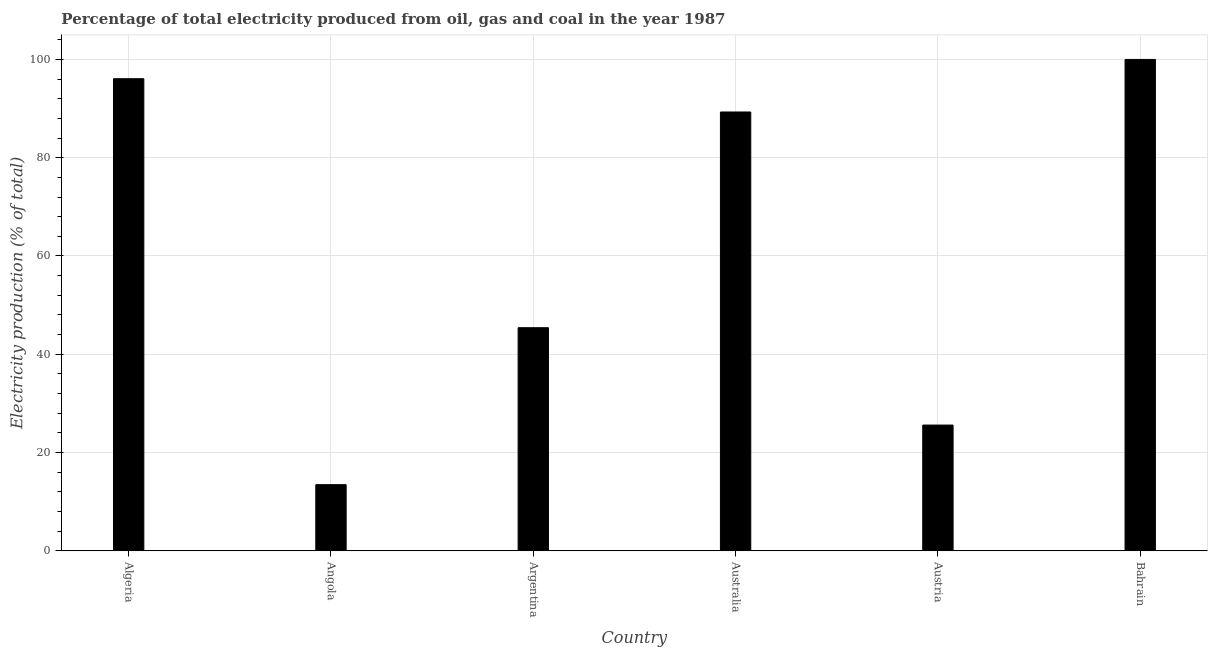Does the graph contain any zero values?
Keep it short and to the point. No. What is the title of the graph?
Your response must be concise. Percentage of total electricity produced from oil, gas and coal in the year 1987. What is the label or title of the Y-axis?
Provide a succinct answer. Electricity production (% of total). Across all countries, what is the minimum electricity production?
Provide a short and direct response. 13.46. In which country was the electricity production maximum?
Your response must be concise. Bahrain. In which country was the electricity production minimum?
Keep it short and to the point. Angola. What is the sum of the electricity production?
Give a very brief answer. 369.82. What is the difference between the electricity production in Argentina and Austria?
Keep it short and to the point. 19.82. What is the average electricity production per country?
Ensure brevity in your answer.  61.64. What is the median electricity production?
Provide a succinct answer. 67.35. In how many countries, is the electricity production greater than 76 %?
Ensure brevity in your answer.  3. What is the ratio of the electricity production in Australia to that in Austria?
Give a very brief answer. 3.49. What is the difference between the highest and the second highest electricity production?
Offer a very short reply. 3.92. What is the difference between the highest and the lowest electricity production?
Keep it short and to the point. 86.54. How many bars are there?
Your answer should be compact. 6. What is the difference between two consecutive major ticks on the Y-axis?
Provide a short and direct response. 20. Are the values on the major ticks of Y-axis written in scientific E-notation?
Offer a terse response. No. What is the Electricity production (% of total) of Algeria?
Offer a terse response. 96.08. What is the Electricity production (% of total) in Angola?
Give a very brief answer. 13.46. What is the Electricity production (% of total) of Argentina?
Your answer should be very brief. 45.4. What is the Electricity production (% of total) of Australia?
Make the answer very short. 89.3. What is the Electricity production (% of total) of Austria?
Provide a short and direct response. 25.58. What is the Electricity production (% of total) of Bahrain?
Give a very brief answer. 100. What is the difference between the Electricity production (% of total) in Algeria and Angola?
Make the answer very short. 82.62. What is the difference between the Electricity production (% of total) in Algeria and Argentina?
Offer a very short reply. 50.68. What is the difference between the Electricity production (% of total) in Algeria and Australia?
Ensure brevity in your answer.  6.77. What is the difference between the Electricity production (% of total) in Algeria and Austria?
Offer a very short reply. 70.49. What is the difference between the Electricity production (% of total) in Algeria and Bahrain?
Make the answer very short. -3.92. What is the difference between the Electricity production (% of total) in Angola and Argentina?
Your answer should be very brief. -31.94. What is the difference between the Electricity production (% of total) in Angola and Australia?
Your answer should be very brief. -75.85. What is the difference between the Electricity production (% of total) in Angola and Austria?
Make the answer very short. -12.13. What is the difference between the Electricity production (% of total) in Angola and Bahrain?
Provide a succinct answer. -86.54. What is the difference between the Electricity production (% of total) in Argentina and Australia?
Keep it short and to the point. -43.91. What is the difference between the Electricity production (% of total) in Argentina and Austria?
Your response must be concise. 19.82. What is the difference between the Electricity production (% of total) in Argentina and Bahrain?
Offer a very short reply. -54.6. What is the difference between the Electricity production (% of total) in Australia and Austria?
Your answer should be compact. 63.72. What is the difference between the Electricity production (% of total) in Australia and Bahrain?
Your answer should be very brief. -10.7. What is the difference between the Electricity production (% of total) in Austria and Bahrain?
Ensure brevity in your answer.  -74.42. What is the ratio of the Electricity production (% of total) in Algeria to that in Angola?
Provide a succinct answer. 7.14. What is the ratio of the Electricity production (% of total) in Algeria to that in Argentina?
Give a very brief answer. 2.12. What is the ratio of the Electricity production (% of total) in Algeria to that in Australia?
Ensure brevity in your answer.  1.08. What is the ratio of the Electricity production (% of total) in Algeria to that in Austria?
Provide a succinct answer. 3.75. What is the ratio of the Electricity production (% of total) in Angola to that in Argentina?
Ensure brevity in your answer.  0.3. What is the ratio of the Electricity production (% of total) in Angola to that in Australia?
Your response must be concise. 0.15. What is the ratio of the Electricity production (% of total) in Angola to that in Austria?
Offer a very short reply. 0.53. What is the ratio of the Electricity production (% of total) in Angola to that in Bahrain?
Provide a short and direct response. 0.14. What is the ratio of the Electricity production (% of total) in Argentina to that in Australia?
Offer a terse response. 0.51. What is the ratio of the Electricity production (% of total) in Argentina to that in Austria?
Your answer should be compact. 1.77. What is the ratio of the Electricity production (% of total) in Argentina to that in Bahrain?
Make the answer very short. 0.45. What is the ratio of the Electricity production (% of total) in Australia to that in Austria?
Provide a succinct answer. 3.49. What is the ratio of the Electricity production (% of total) in Australia to that in Bahrain?
Offer a very short reply. 0.89. What is the ratio of the Electricity production (% of total) in Austria to that in Bahrain?
Offer a terse response. 0.26. 